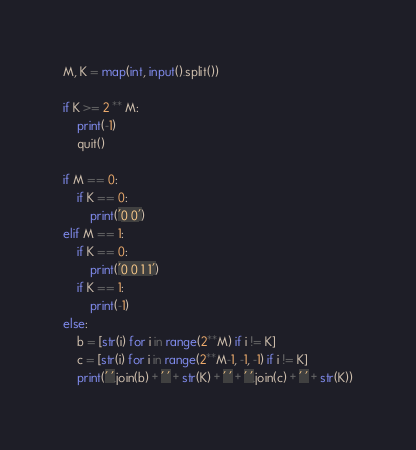<code> <loc_0><loc_0><loc_500><loc_500><_Python_>M, K = map(int, input().split())

if K >= 2 ** M:
    print(-1)
    quit()

if M == 0:
    if K == 0:
        print('0 0')
elif M == 1:
    if K == 0:
        print('0 0 1 1')
    if K == 1:
        print(-1)
else:
    b = [str(i) for i in range(2**M) if i != K]
    c = [str(i) for i in range(2**M-1, -1, -1) if i != K]
    print(' '.join(b) + ' ' + str(K) + ' ' + ' '.join(c) + ' ' + str(K))</code> 